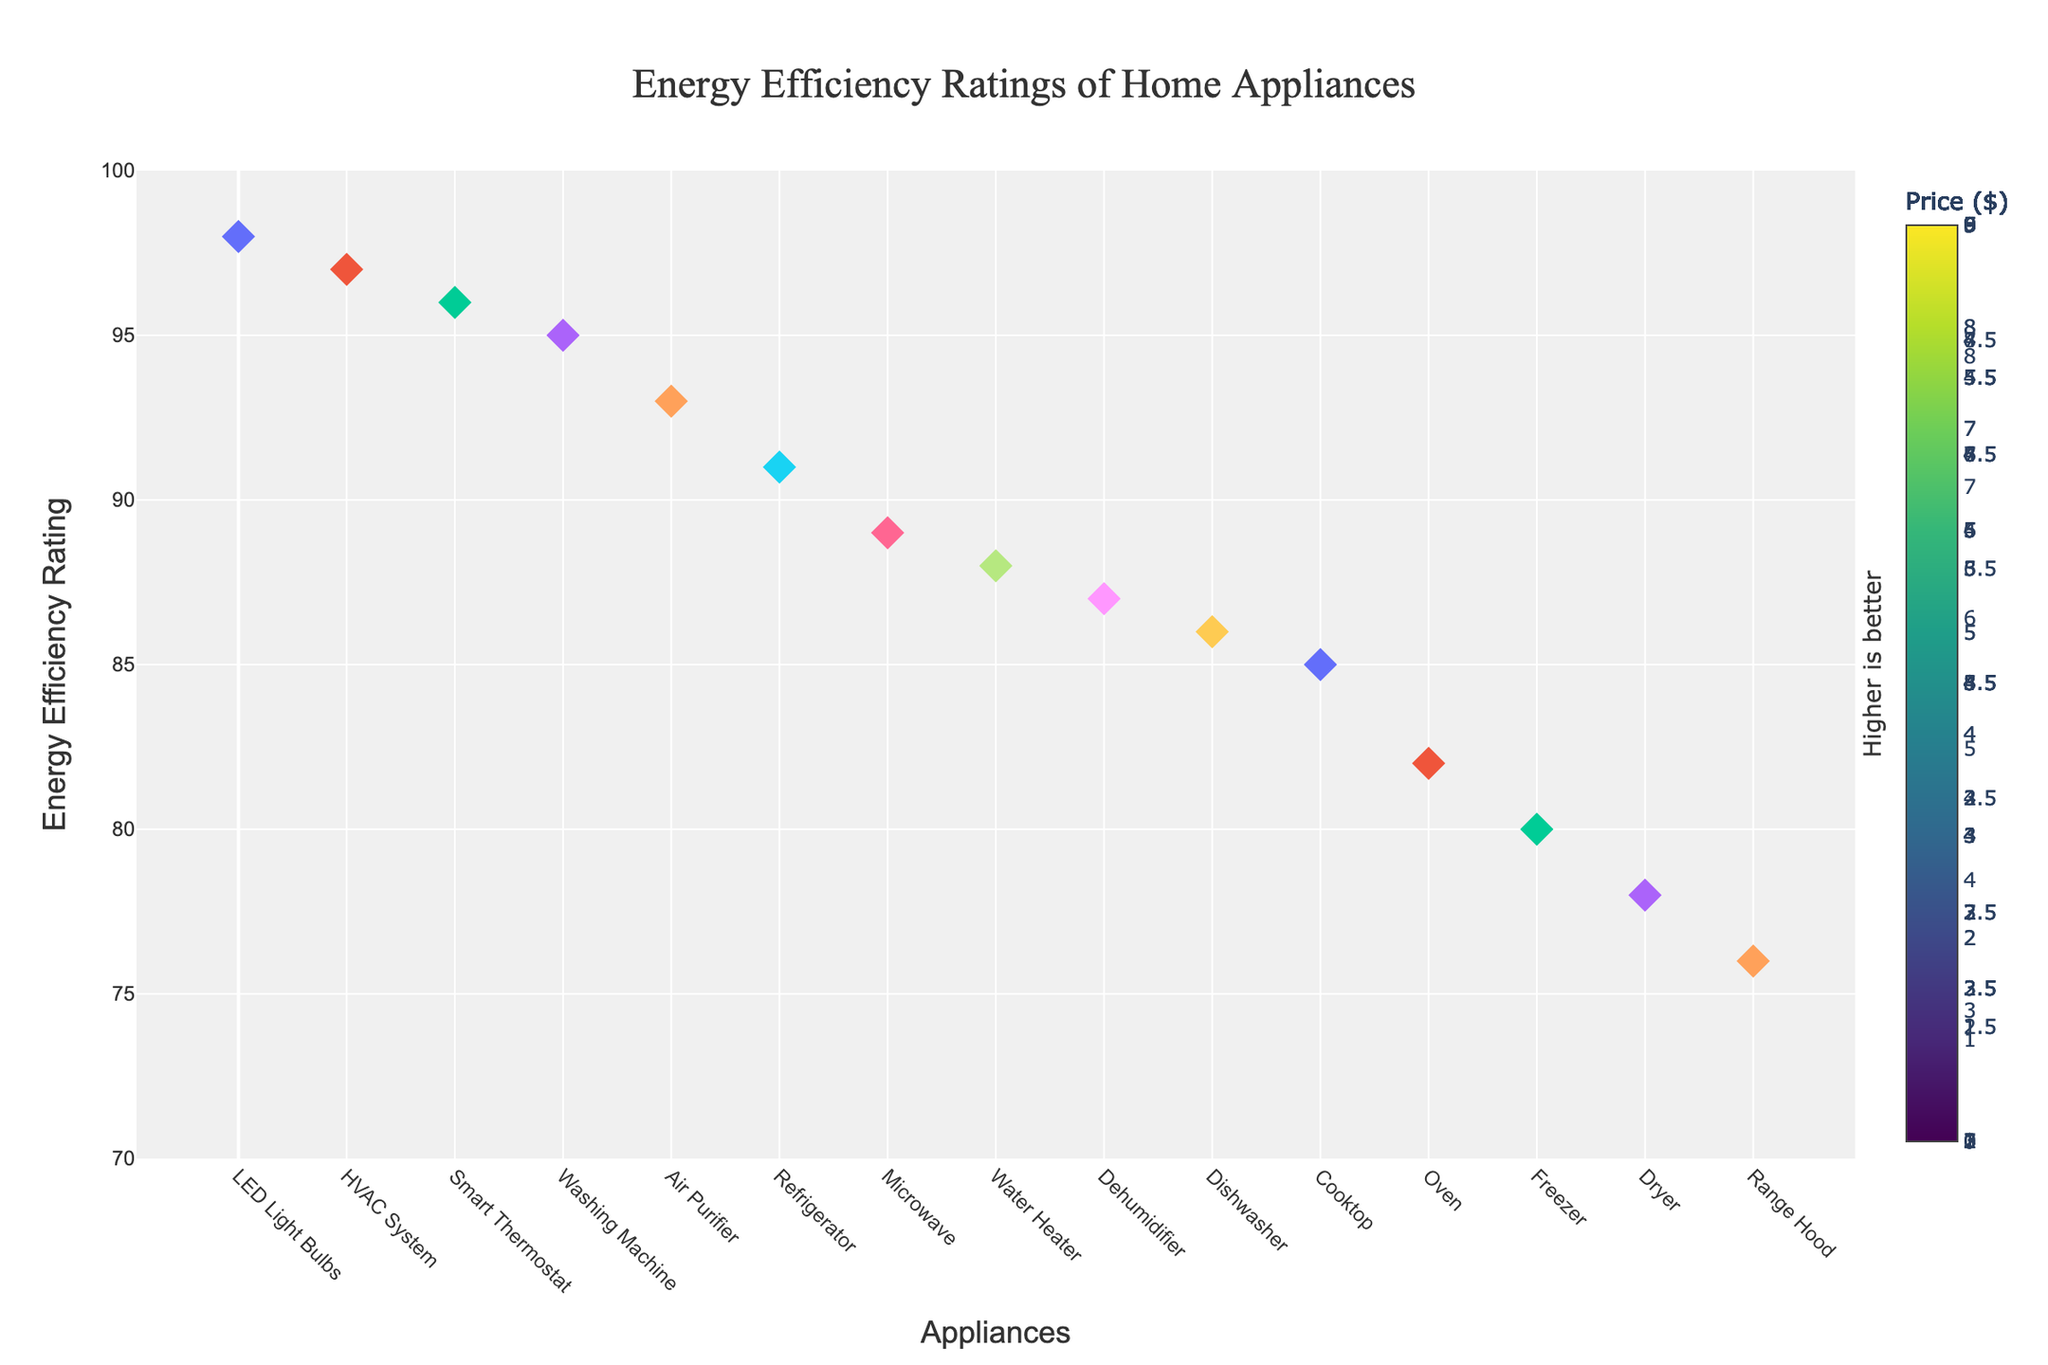What is the title of the figure? The title of the figure is displayed at the top and provides an overview of what the figure is about.
Answer: Energy Efficiency Ratings of Home Appliances How many appliances were analyzed in the figure? To find the number of analyzed appliances, count the number of distinct markers on the plot.
Answer: 14 Which appliance has the highest energy efficiency rating? Look for the marker with the highest y-value on the plot.
Answer: LED Light Bulbs What is the price of the appliance with the lowest energy efficiency rating? Find the marker with the lowest y-value, then check the corresponding color which indicates the price according to the color bar.
Answer: $399 Which appliance brand has a model with an energy efficiency rating of 89? Locate the marker at the y-value of 89, then refer to the hover text for the brand name.
Answer: Panasonic What is the average energy efficiency rating of the washing machine and smart thermostat? Find the ratings for both appliances (95 for Washing Machine and 96 for Smart Thermostat), add them together, and divide by 2.
Answer: 95.5 Compare the energy efficiency ratings of the refrigerator and air purifier. Which one is higher? Find the y-values for both the refrigerator and air purifier, and compare them. Refrigerator has a rating of 91 and air purifier has a rating of 93.
Answer: Air Purifier What is the difference in the energy efficiency rating between the dishwasher and the range hood? Find the y-values (ratings) for both appliances (86 for Dishwasher and 76 for Range Hood) and subtract the smaller value from the larger one.
Answer: 10 Which appliance has a rating higher than 90 and a price lower than $600? Locate markers with y-values above 90, then use the color bar to find markers colored in the range corresponding to prices below $600, and refer to the hover text for confirmation.
Answer: Air Purifier What is the combined price of the refrigerator and the washing machine? Find the prices for both appliances ($3199 for Refrigerator and $1099 for Washing Machine) and add them together.
Answer: $4298 